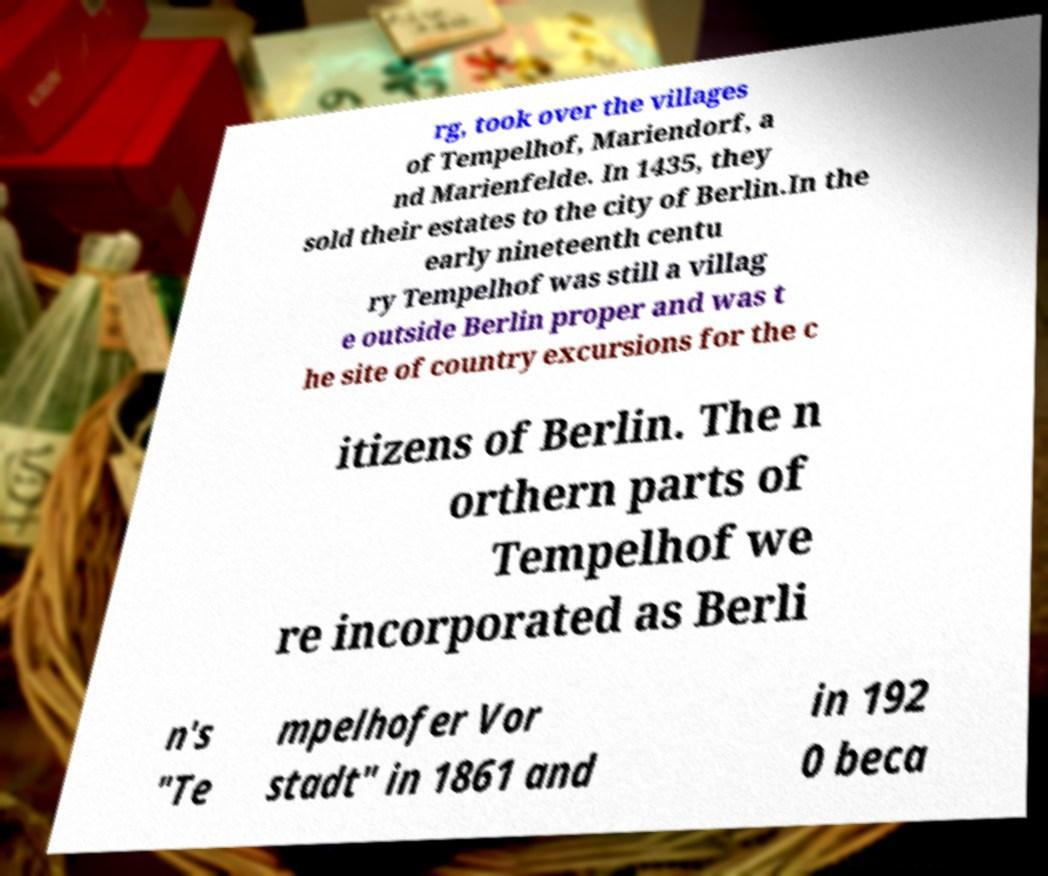What messages or text are displayed in this image? I need them in a readable, typed format. rg, took over the villages of Tempelhof, Mariendorf, a nd Marienfelde. In 1435, they sold their estates to the city of Berlin.In the early nineteenth centu ry Tempelhof was still a villag e outside Berlin proper and was t he site of country excursions for the c itizens of Berlin. The n orthern parts of Tempelhof we re incorporated as Berli n's "Te mpelhofer Vor stadt" in 1861 and in 192 0 beca 